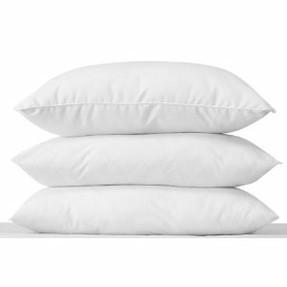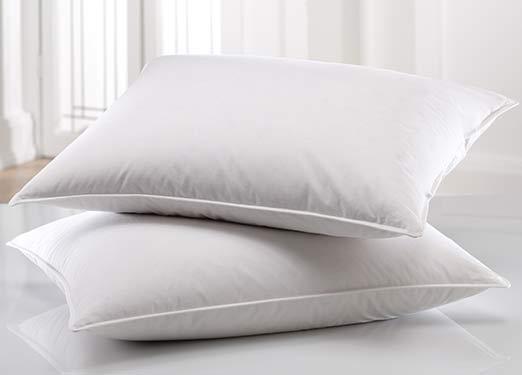The first image is the image on the left, the second image is the image on the right. For the images shown, is this caption "There is only one pillow in one of the images." true? Answer yes or no. No. The first image is the image on the left, the second image is the image on the right. For the images shown, is this caption "There are three pillows in the pair of images." true? Answer yes or no. No. 